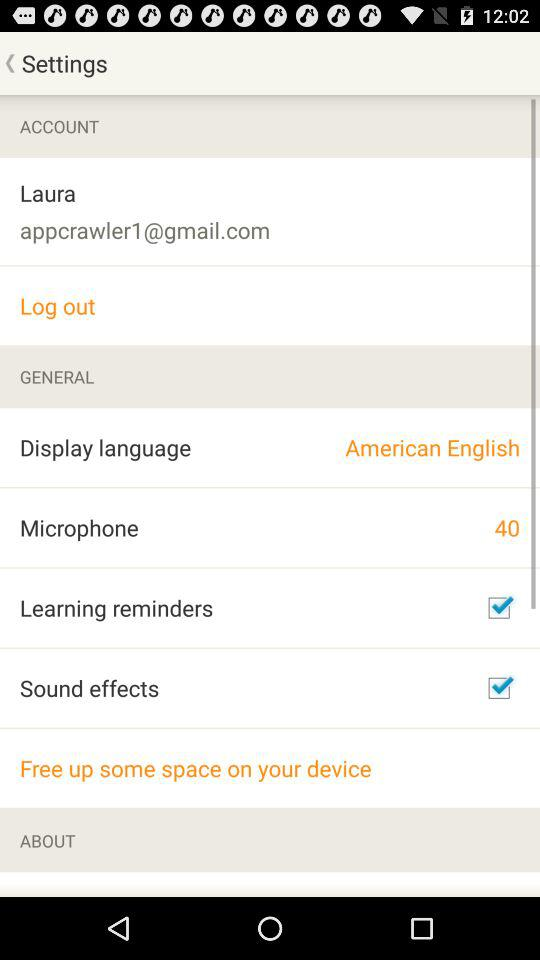What is the selected display language? The selected display language is American English. 